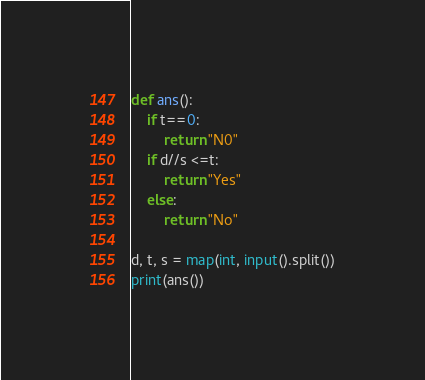Convert code to text. <code><loc_0><loc_0><loc_500><loc_500><_Python_>def ans():
    if t==0:
        return "N0"
    if d//s <=t:
        return "Yes"
    else:
        return "No"
        
d, t, s = map(int, input().split())
print(ans())</code> 